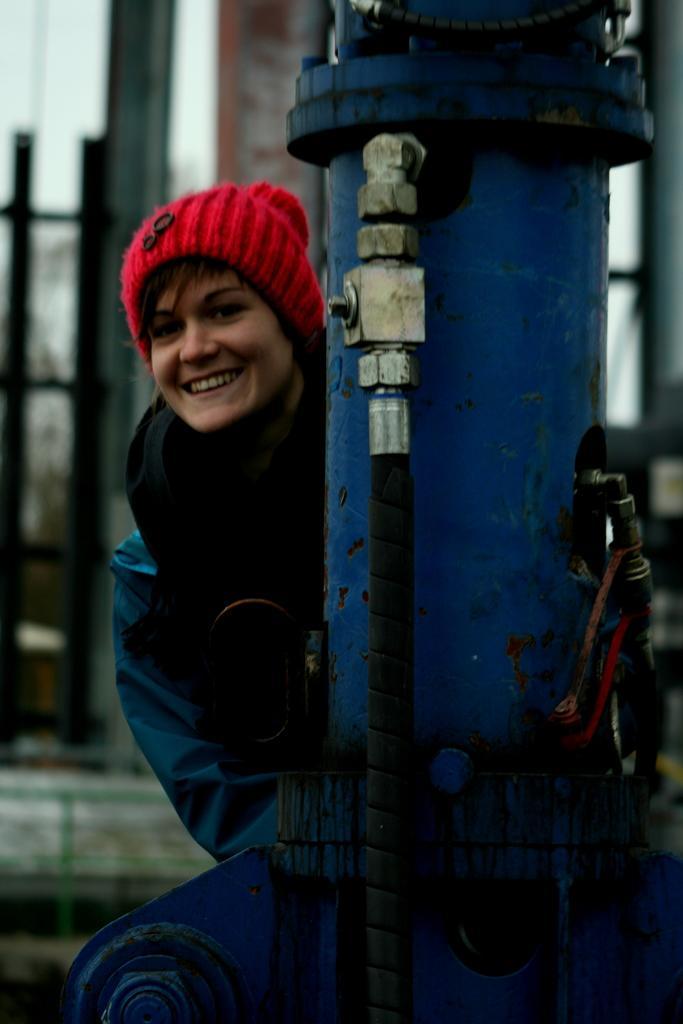Please provide a concise description of this image. In this picture I can see a blue color thing and behind it I see a woman who is smiling and I see that it is blurred in the background. 